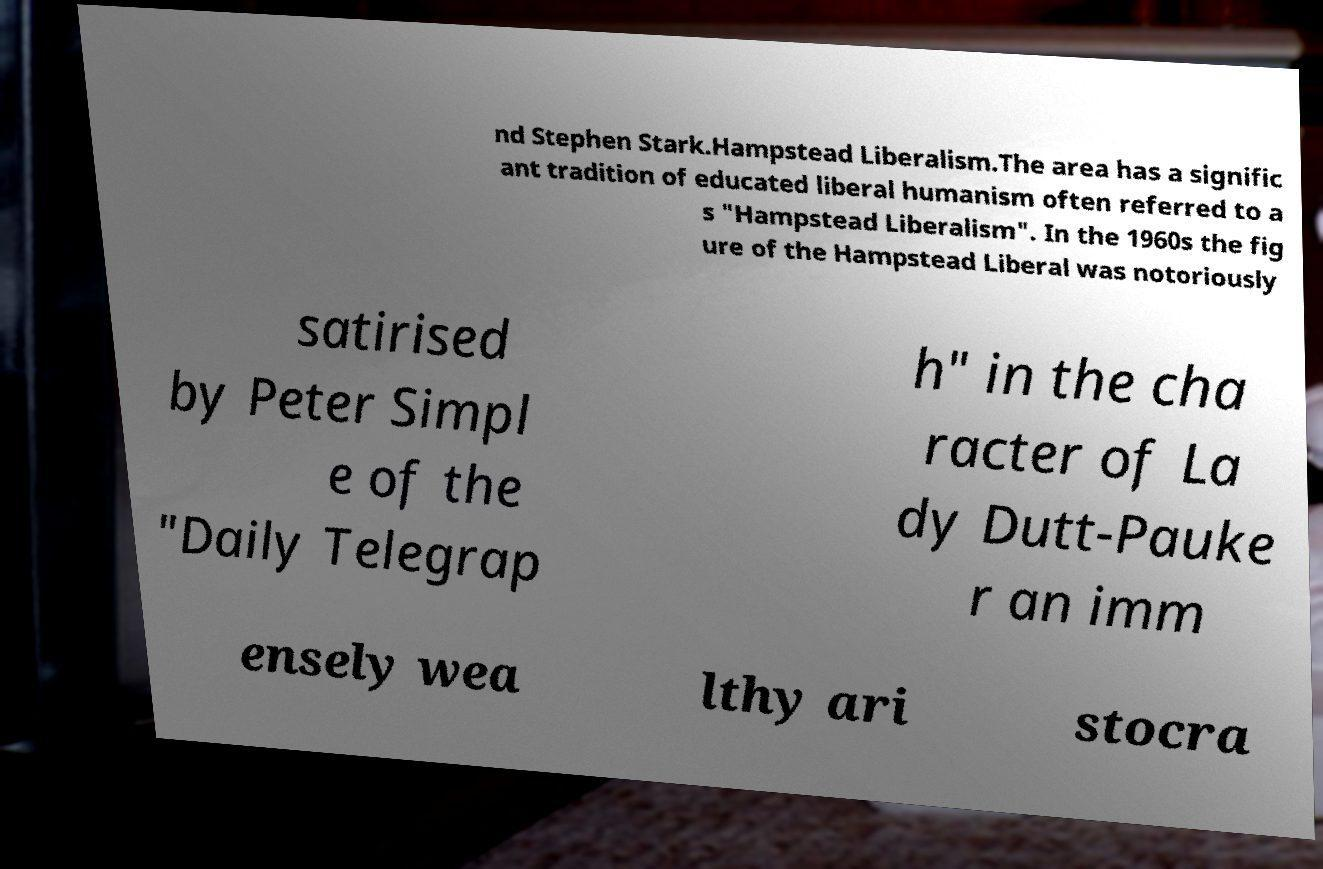There's text embedded in this image that I need extracted. Can you transcribe it verbatim? nd Stephen Stark.Hampstead Liberalism.The area has a signific ant tradition of educated liberal humanism often referred to a s "Hampstead Liberalism". In the 1960s the fig ure of the Hampstead Liberal was notoriously satirised by Peter Simpl e of the "Daily Telegrap h" in the cha racter of La dy Dutt-Pauke r an imm ensely wea lthy ari stocra 